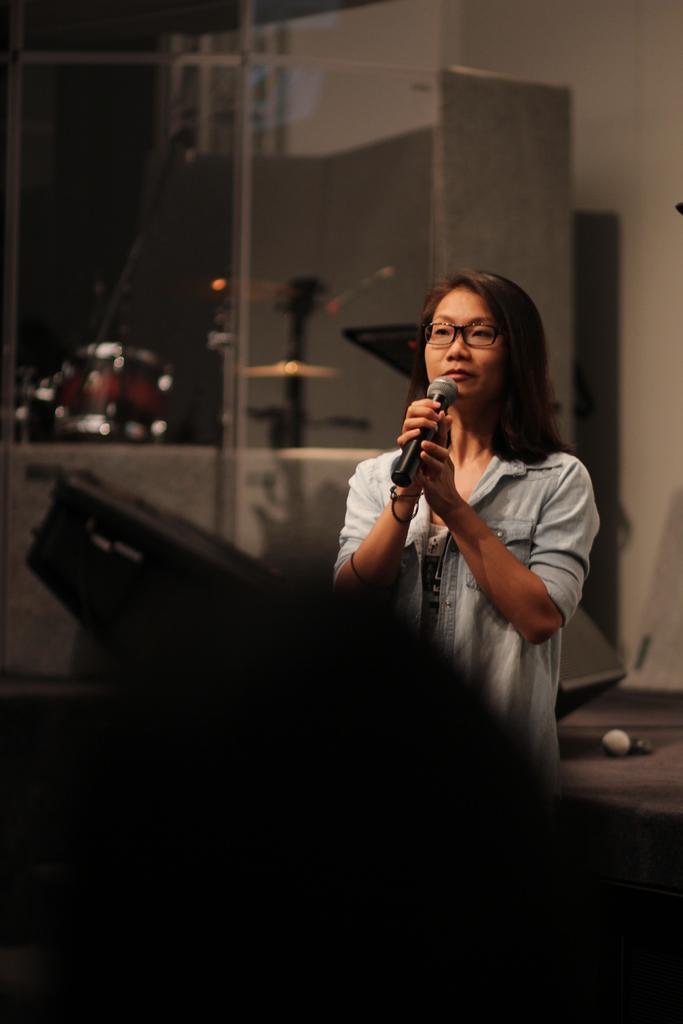Can you describe this image briefly? In the picture I can see a woman is holding a microphone in hands and wearing spectacles. In the background I can see objects. The background of the image is blurred. 